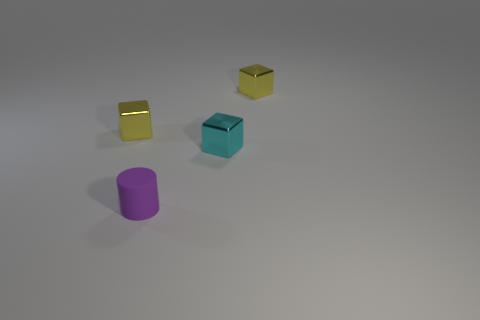Add 4 tiny purple matte things. How many objects exist? 8 Subtract all cylinders. How many objects are left? 3 Add 1 small purple cubes. How many small purple cubes exist? 1 Subtract 0 gray spheres. How many objects are left? 4 Subtract all brown metallic things. Subtract all small objects. How many objects are left? 0 Add 4 metal cubes. How many metal cubes are left? 7 